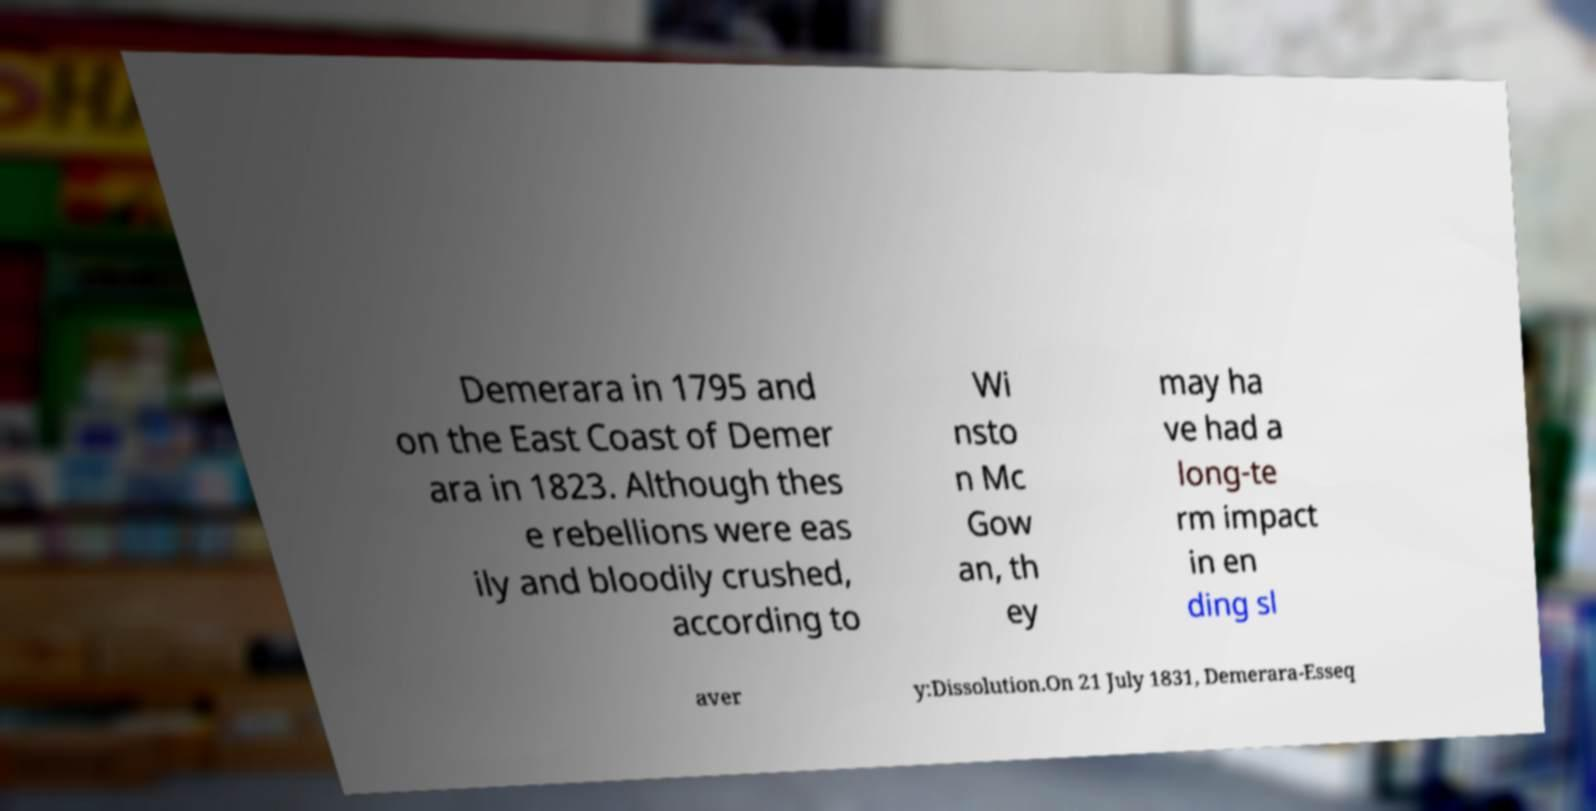Can you accurately transcribe the text from the provided image for me? Demerara in 1795 and on the East Coast of Demer ara in 1823. Although thes e rebellions were eas ily and bloodily crushed, according to Wi nsto n Mc Gow an, th ey may ha ve had a long-te rm impact in en ding sl aver y:Dissolution.On 21 July 1831, Demerara-Esseq 